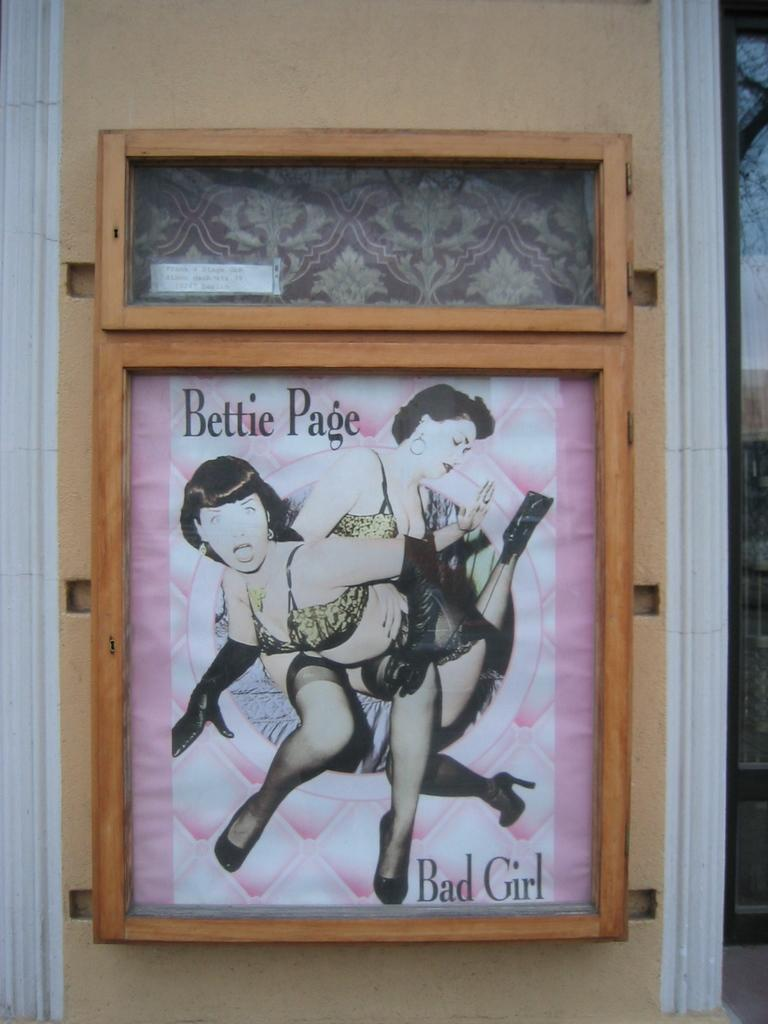<image>
Present a compact description of the photo's key features. A poster in a frame with the text Bettie Page Bad Girl. 